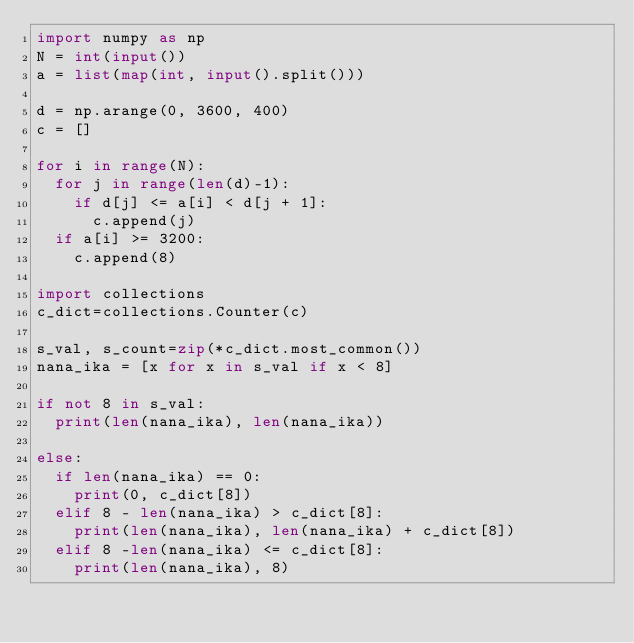<code> <loc_0><loc_0><loc_500><loc_500><_Python_>import numpy as np
N = int(input())
a = list(map(int, input().split()))

d = np.arange(0, 3600, 400)
c = []

for i in range(N):
	for j in range(len(d)-1):
		if d[j] <= a[i] < d[j + 1]:
			c.append(j)
	if a[i] >= 3200:
		c.append(8)

import collections
c_dict=collections.Counter(c)

s_val, s_count=zip(*c_dict.most_common())
nana_ika = [x for x in s_val if x < 8]

if not 8 in s_val:
	print(len(nana_ika), len(nana_ika))

else:
	if len(nana_ika) == 0:
		print(0, c_dict[8])
	elif 8 - len(nana_ika) > c_dict[8]:
		print(len(nana_ika), len(nana_ika) + c_dict[8])
	elif 8 -len(nana_ika) <= c_dict[8]:
		print(len(nana_ika), 8)

</code> 